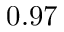Convert formula to latex. <formula><loc_0><loc_0><loc_500><loc_500>0 . 9 7</formula> 